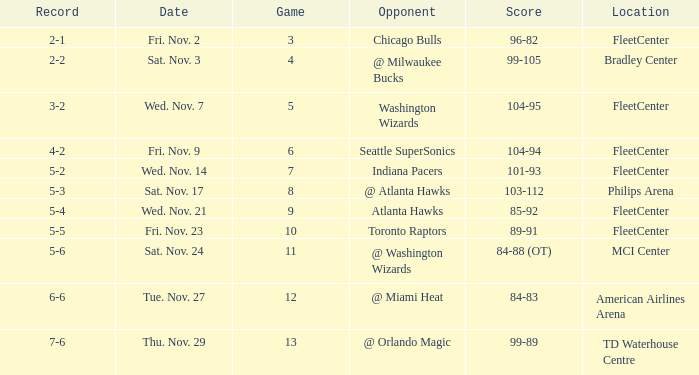What game has a score of 89-91? 10.0. 